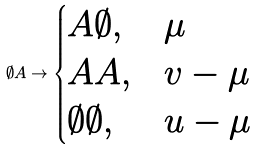<formula> <loc_0><loc_0><loc_500><loc_500>\emptyset A \to \begin{cases} A \emptyset , & \mu \\ A A , & v - \mu \\ \emptyset \emptyset , & u - \mu \end{cases}</formula> 